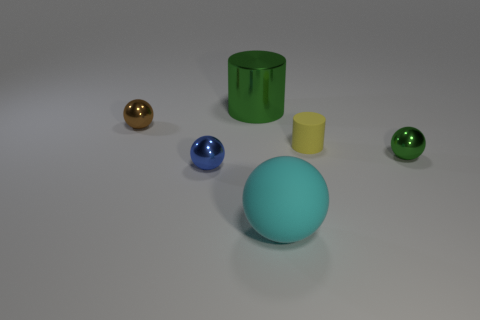Subtract all big matte spheres. How many spheres are left? 3 Subtract all cyan spheres. How many spheres are left? 3 Add 3 big green metallic balls. How many objects exist? 9 Add 1 yellow matte things. How many yellow matte things are left? 2 Add 2 brown metallic objects. How many brown metallic objects exist? 3 Subtract 0 red spheres. How many objects are left? 6 Subtract all cylinders. How many objects are left? 4 Subtract 3 spheres. How many spheres are left? 1 Subtract all green balls. Subtract all red cylinders. How many balls are left? 3 Subtract all cyan spheres. How many yellow cylinders are left? 1 